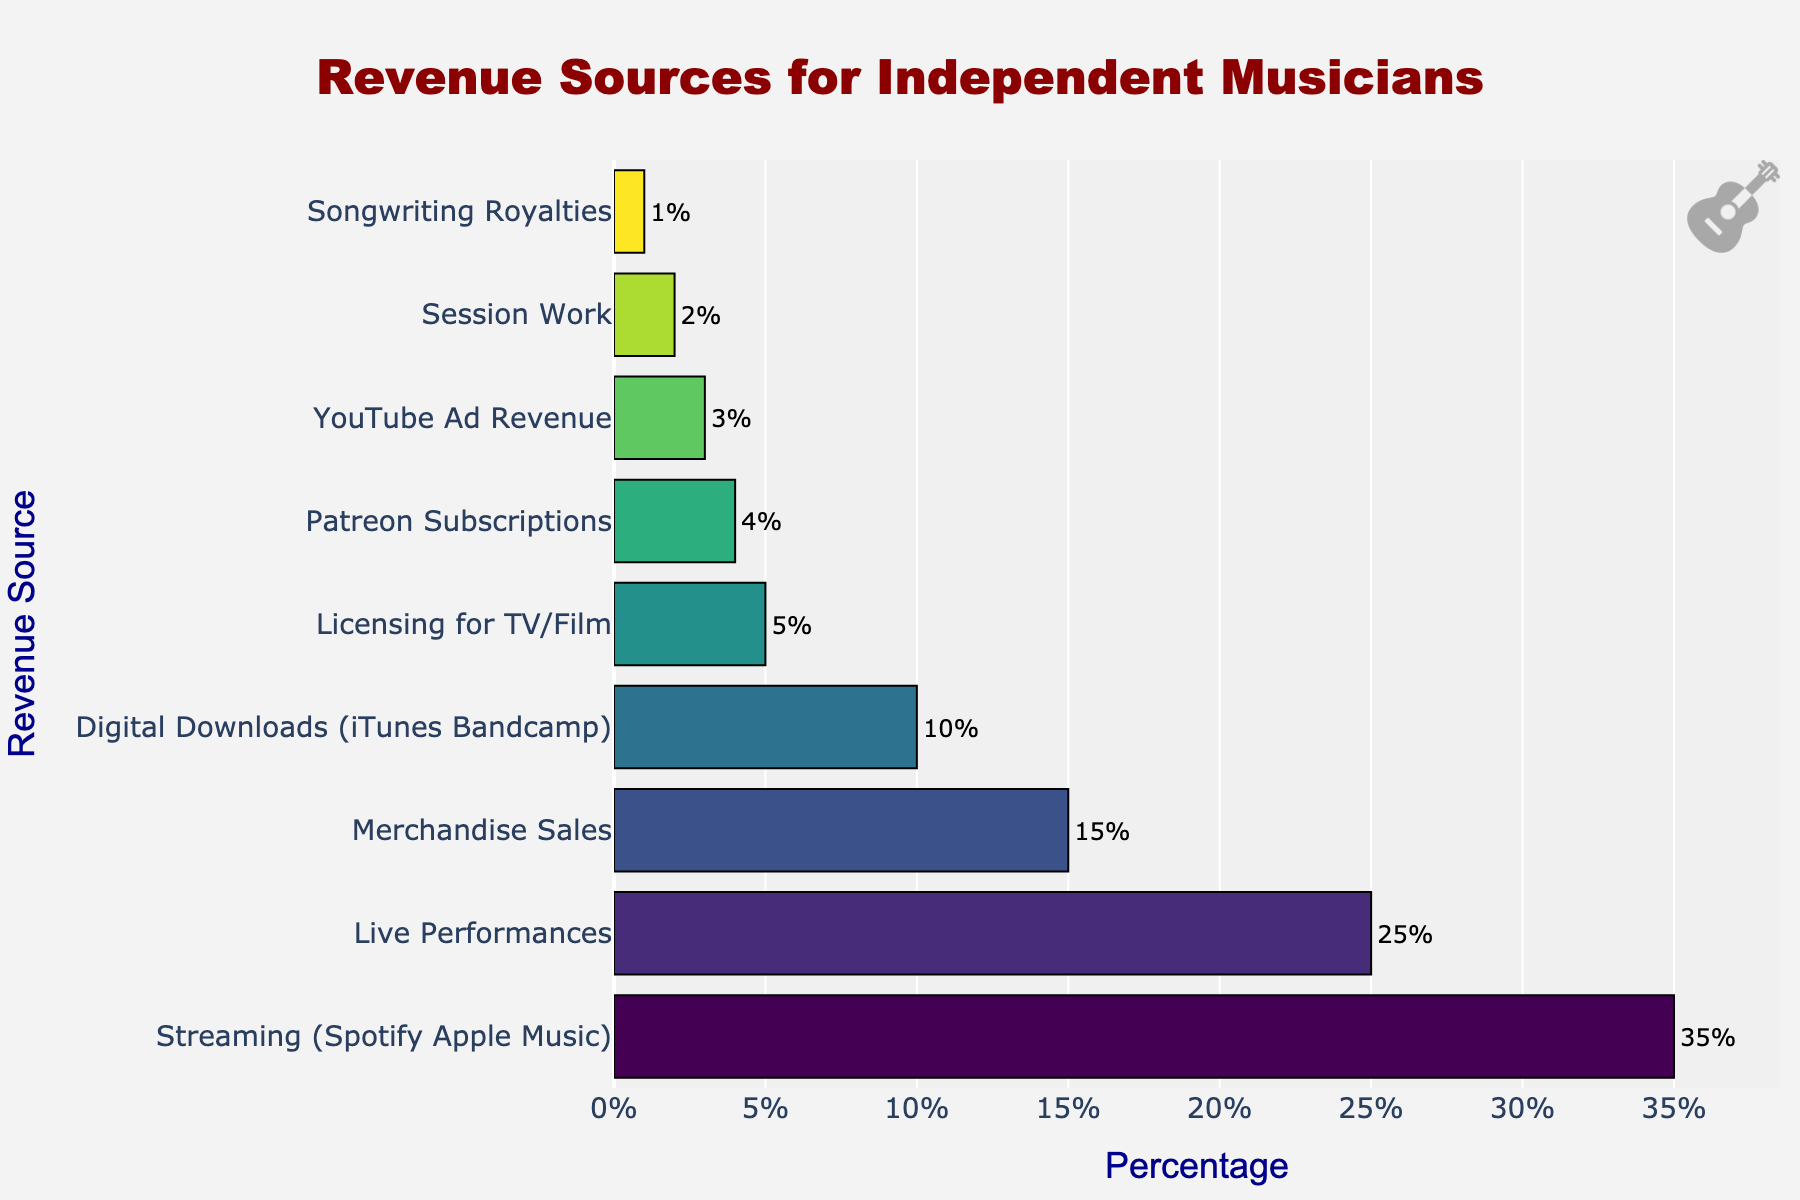Which revenue source has the highest percentage? The data shows that "Streaming (Spotify Apple Music)" is positioned at the top of the chart with the highest percentage.
Answer: Streaming (Spotify Apple Music) What is the combined percentage of Live Performances and Merchandise Sales? The percentage for Live Performances is 25% and for Merchandise Sales is 15%. Adding these together gives 25% + 15% = 40%.
Answer: 40% Which revenue source contributes the least to the total percentage? The chart shows that "Songwriting Royalties" has the smallest bar, indicating the lowest percentage at 1%.
Answer: Songwriting Royalties How much smaller is YouTube Ad Revenue compared to Streaming (Spotify Apple Music)? The percentage for YouTube Ad Revenue is 3%, and for Streaming (Spotify Apple Music) it is 35%. The difference is 35% - 3% = 32%.
Answer: 32% What is the average percentage of Digital Downloads and Licensing for TV/Film? The percentage for Digital Downloads is 10% and for Licensing for TV/Film is 5%. Averaging these values gives (10% + 5%) / 2 = 7.5%.
Answer: 7.5% Is Merchandise Sales greater than twice the percentage of Patreon Subscriptions? The percentage for Merchandise Sales is 15% and for Patreon Subscriptions is 4%. Twice Patreon Subscriptions is 4% * 2 = 8%. Since 15% is greater than 8%, the answer is yes.
Answer: Yes How much larger is Live Performances than Session Work? Live Performances are 25% and Session Work is 2%. The difference is 25% - 2% = 23%.
Answer: 23% Do Live Performances and Digital Downloads together contribute more than Streaming? Live Performances contribute 25% and Digital Downloads contribute 10%. Together they contribute 25% + 10% = 35%, which is equal to the contribution of Streaming, both are 35%.
Answer: No If you sum the percentages of Licensing for TV/Film, Patreon Subscriptions, YouTube Ad Revenue, and Session Work, do they exceed Merchandise Sales? Licensing for TV/Film is 5%, Patreon Subscriptions is 4%, YouTube Ad Revenue is 3%, and Session Work is 2%. Summing these percentages we have 5% + 4% + 3% + 2% = 14%, which is less than 15% for Merchandise Sales.
Answer: No 